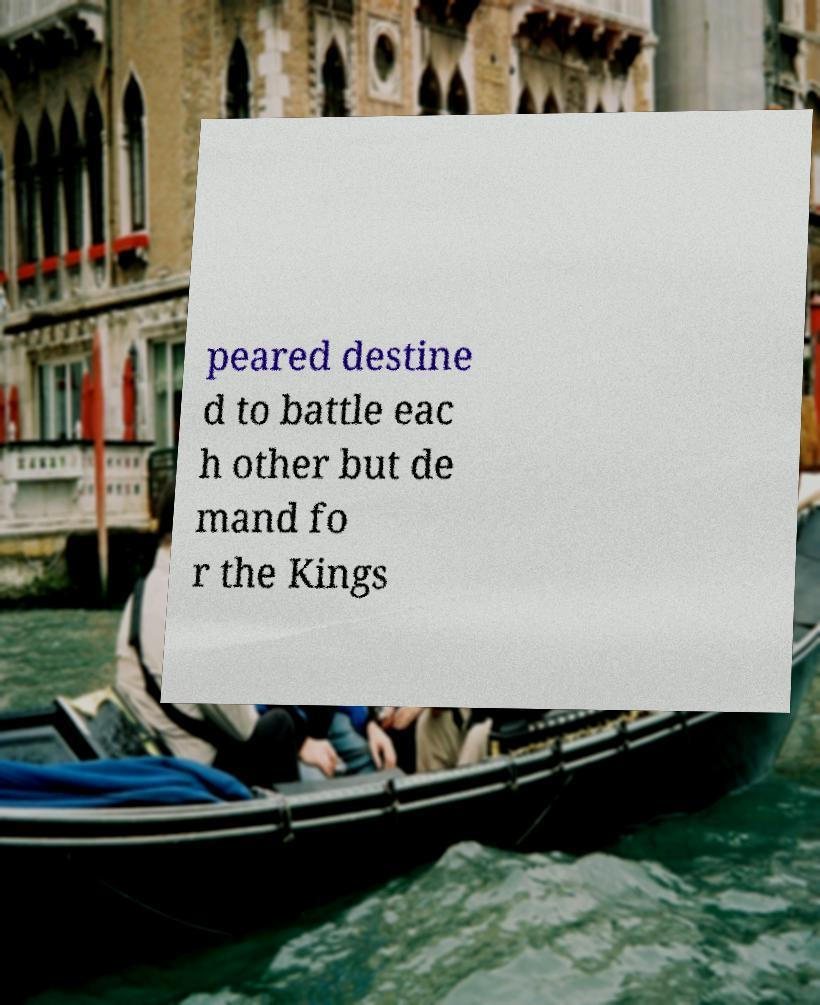What messages or text are displayed in this image? I need them in a readable, typed format. peared destine d to battle eac h other but de mand fo r the Kings 